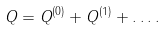Convert formula to latex. <formula><loc_0><loc_0><loc_500><loc_500>Q = Q ^ { ( 0 ) } + Q ^ { ( 1 ) } + \dots .</formula> 